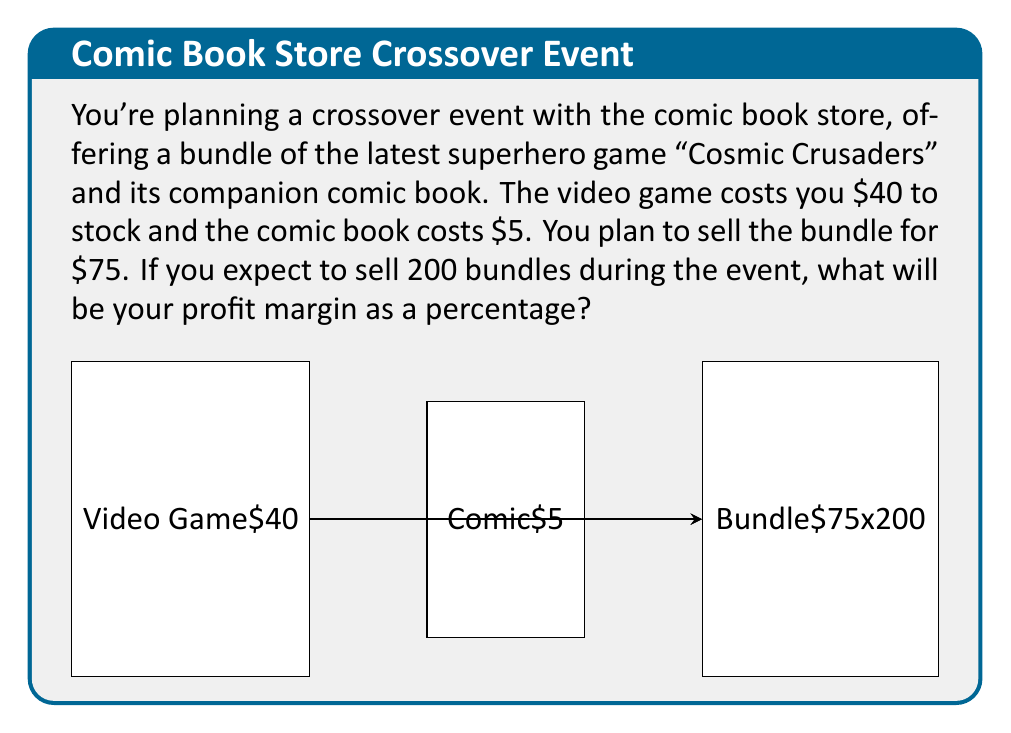Give your solution to this math problem. Let's break this down step-by-step:

1) First, calculate the cost of each bundle:
   Cost per bundle = Cost of video game + Cost of comic book
   $$ \text{Cost per bundle} = $40 + $5 = $45 $$

2) Calculate the revenue from selling 200 bundles:
   $$ \text{Revenue} = 200 \times $75 = $15,000 $$

3) Calculate the total cost for 200 bundles:
   $$ \text{Total Cost} = 200 \times $45 = $9,000 $$

4) Calculate the profit:
   $$ \text{Profit} = \text{Revenue} - \text{Total Cost} = $15,000 - $9,000 = $6,000 $$

5) Calculate the profit margin:
   $$ \text{Profit Margin} = \frac{\text{Profit}}{\text{Revenue}} \times 100\% $$
   $$ = \frac{$6,000}{$15,000} \times 100\% = 0.4 \times 100\% = 40\% $$

Therefore, your profit margin for this bundle during the crossover event will be 40%.
Answer: 40% 